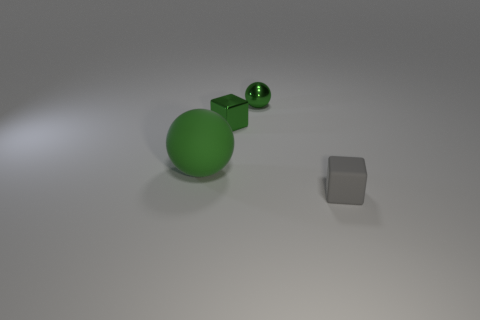Subtract all yellow balls. Subtract all blue cubes. How many balls are left? 2 Subtract all purple balls. How many blue blocks are left? 0 Add 4 tiny things. How many greens exist? 0 Subtract all gray things. Subtract all large green rubber balls. How many objects are left? 2 Add 1 small green shiny spheres. How many small green shiny spheres are left? 2 Add 4 tiny rubber things. How many tiny rubber things exist? 5 Add 4 green shiny objects. How many objects exist? 8 Subtract all green blocks. How many blocks are left? 1 Subtract 0 cyan cylinders. How many objects are left? 4 How many green balls must be subtracted to get 1 green balls? 1 